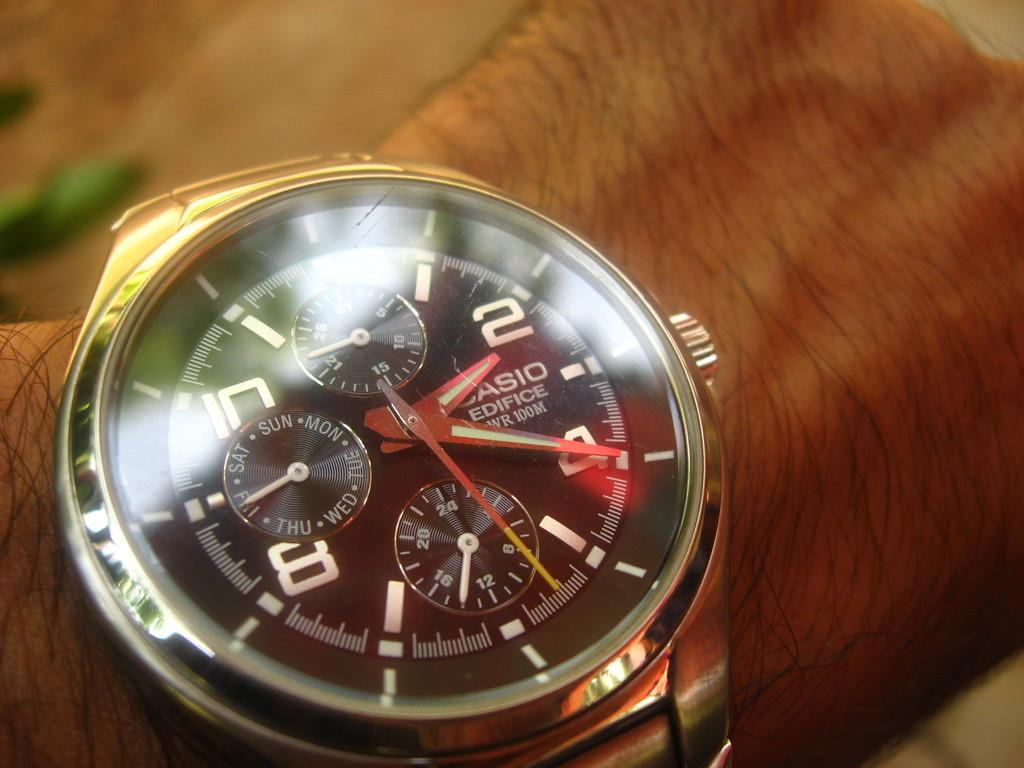<image>
Create a compact narrative representing the image presented. A person wears a Casio watch with many small dials on their wrist. 